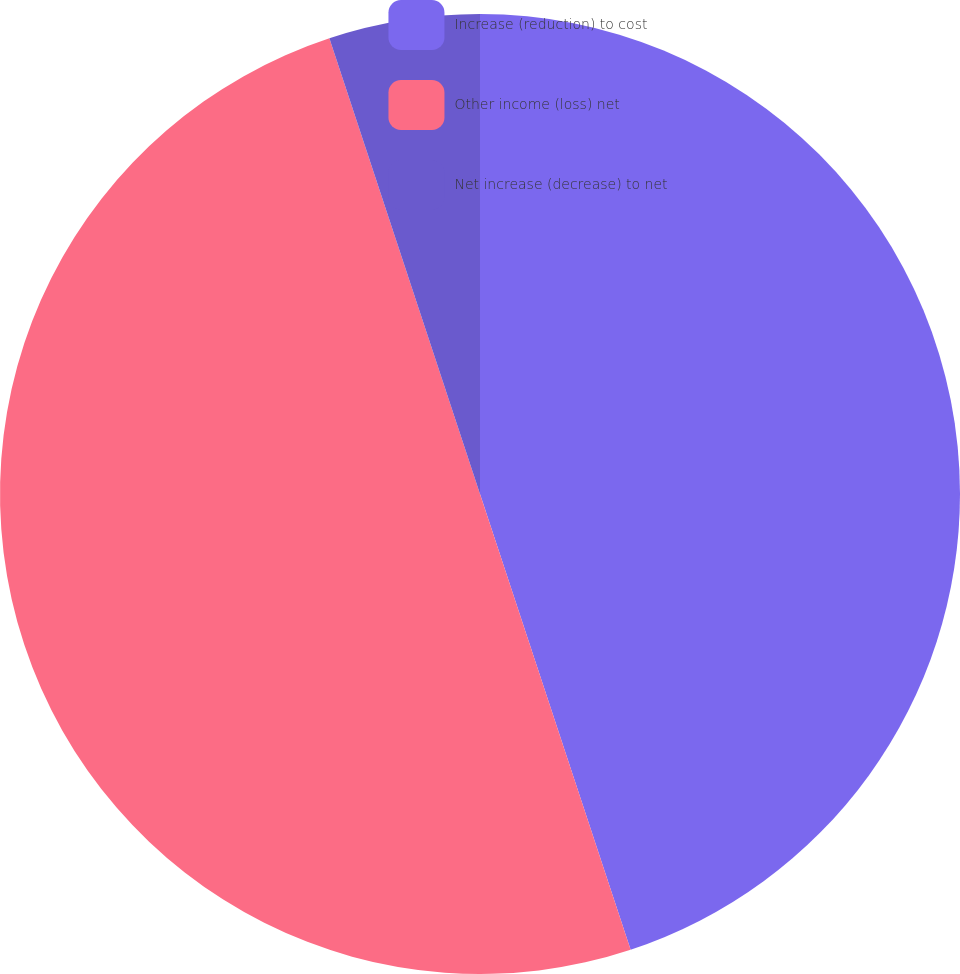Convert chart. <chart><loc_0><loc_0><loc_500><loc_500><pie_chart><fcel>Increase (reduction) to cost<fcel>Other income (loss) net<fcel>Net increase (decrease) to net<nl><fcel>44.92%<fcel>50.0%<fcel>5.08%<nl></chart> 